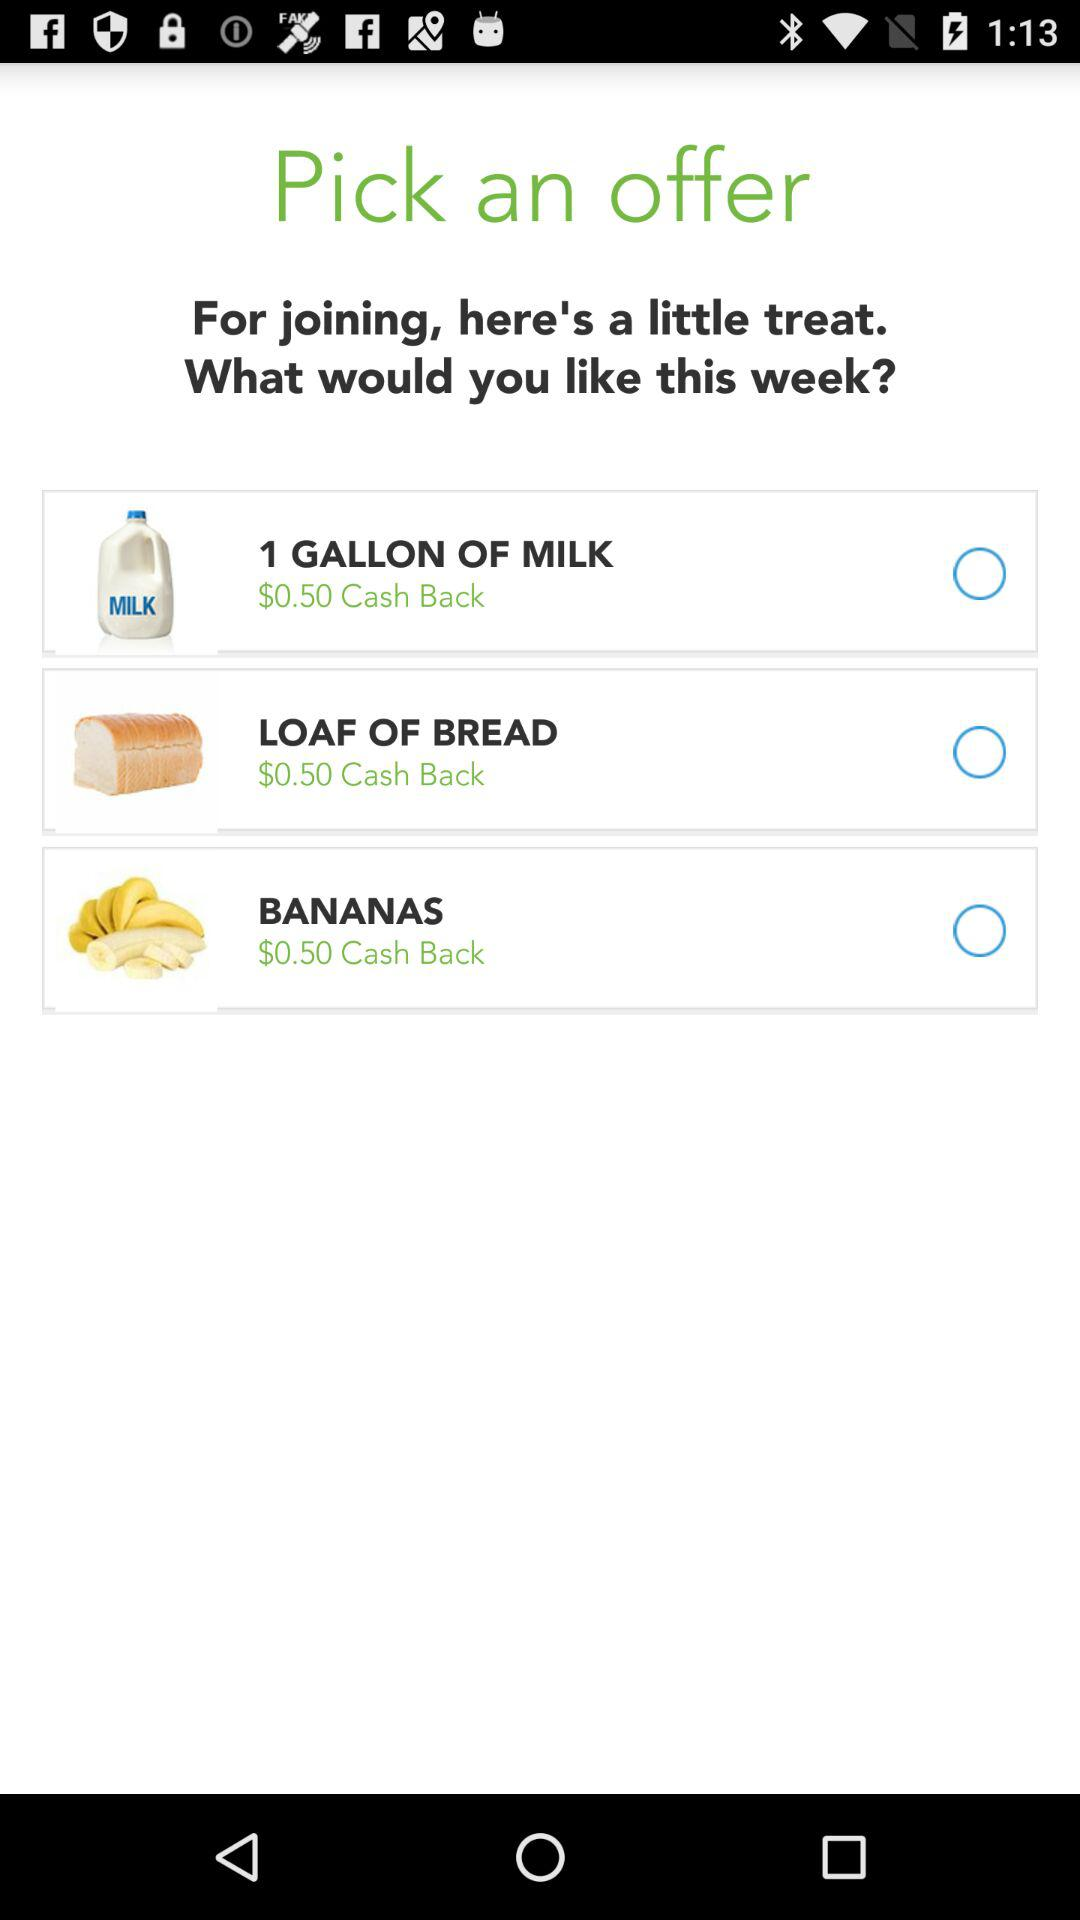How much cash back is on bananas? Cash back on bananas is $0.50. 